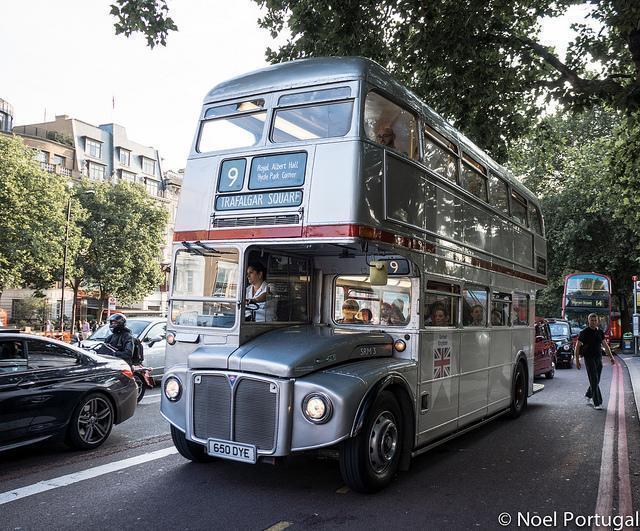In which country does this bus drive?
From the following four choices, select the correct answer to address the question.
Options: Usa, united kingdom, belgium, france. United kingdom. 